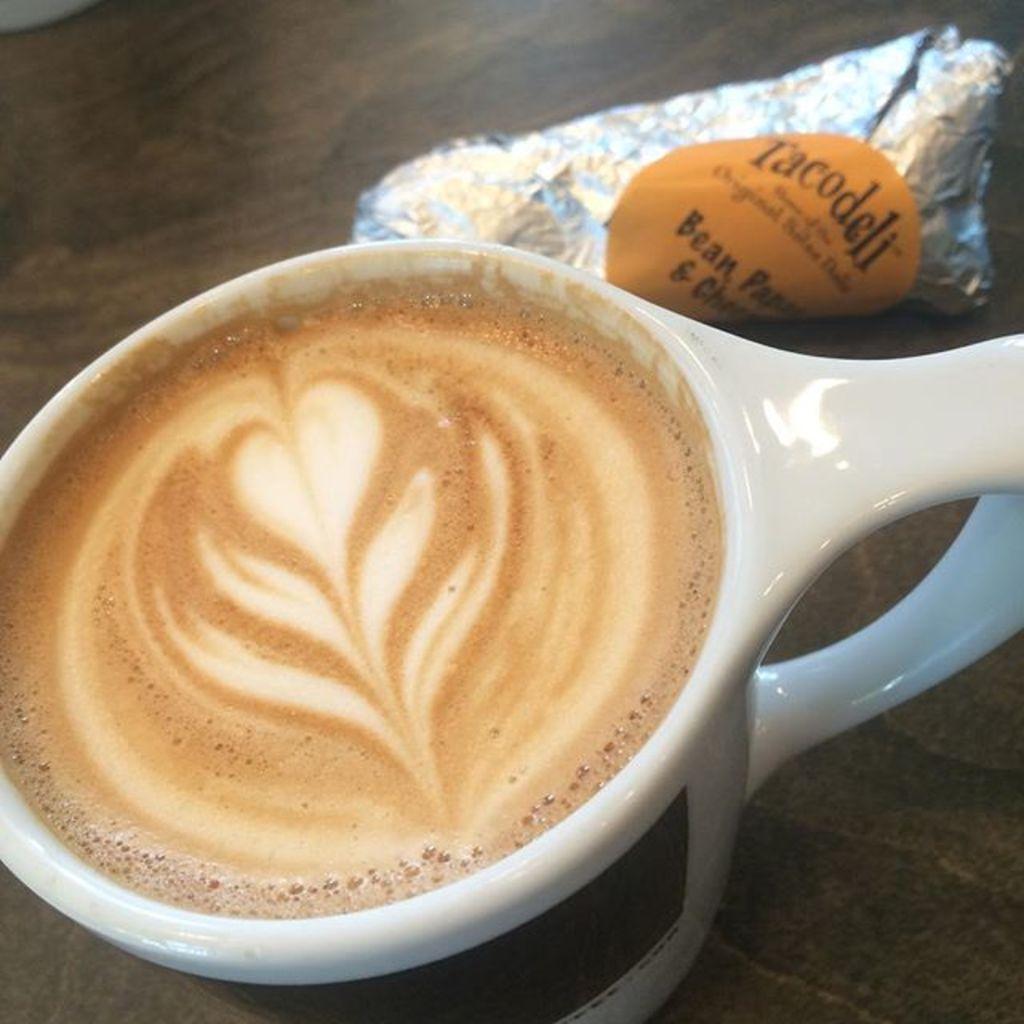Describe this image in one or two sentences. In this image we can see a table, a coffee cup on a table and an object beside the cup. 